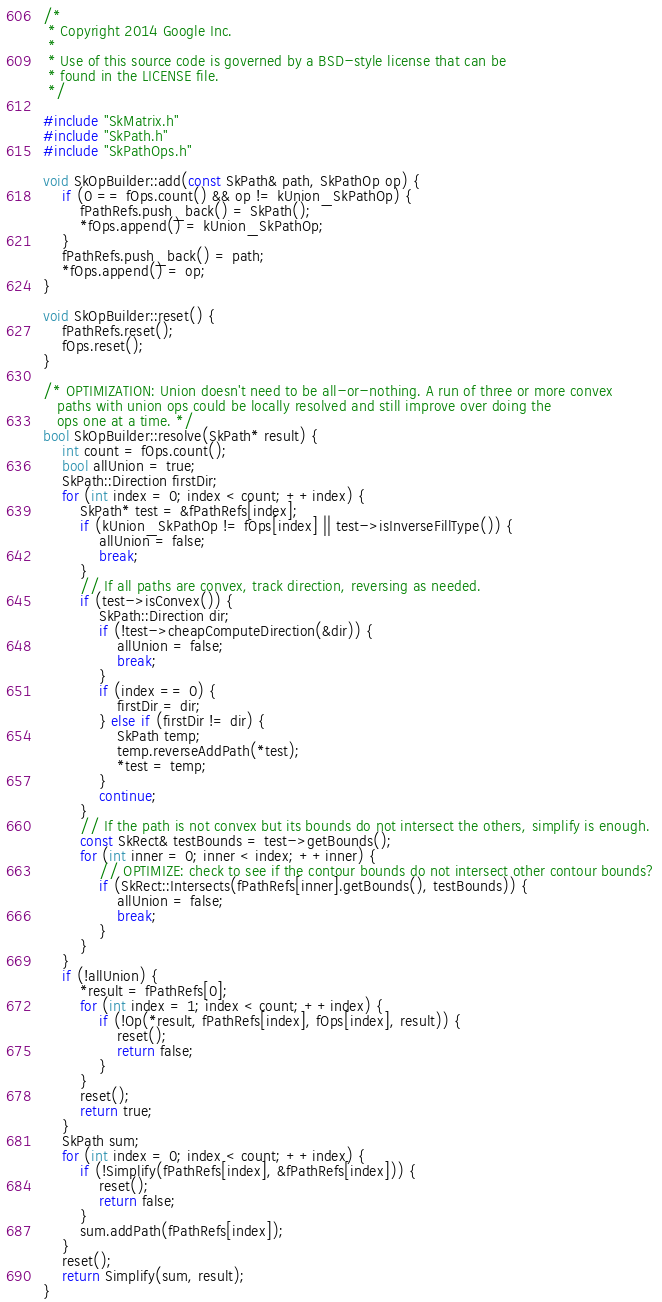<code> <loc_0><loc_0><loc_500><loc_500><_C++_>/*
 * Copyright 2014 Google Inc.
 *
 * Use of this source code is governed by a BSD-style license that can be
 * found in the LICENSE file.
 */

#include "SkMatrix.h"
#include "SkPath.h"
#include "SkPathOps.h"

void SkOpBuilder::add(const SkPath& path, SkPathOp op) {
    if (0 == fOps.count() && op != kUnion_SkPathOp) {
        fPathRefs.push_back() = SkPath();
        *fOps.append() = kUnion_SkPathOp;
    }
    fPathRefs.push_back() = path;
    *fOps.append() = op;
}

void SkOpBuilder::reset() {
    fPathRefs.reset();
    fOps.reset();
}

/* OPTIMIZATION: Union doesn't need to be all-or-nothing. A run of three or more convex
   paths with union ops could be locally resolved and still improve over doing the
   ops one at a time. */
bool SkOpBuilder::resolve(SkPath* result) {
    int count = fOps.count();
    bool allUnion = true;
    SkPath::Direction firstDir;
    for (int index = 0; index < count; ++index) {
        SkPath* test = &fPathRefs[index];
        if (kUnion_SkPathOp != fOps[index] || test->isInverseFillType()) {
            allUnion = false;
            break;
        }
        // If all paths are convex, track direction, reversing as needed.
        if (test->isConvex()) {
            SkPath::Direction dir;
            if (!test->cheapComputeDirection(&dir)) {
                allUnion = false;
                break;
            }
            if (index == 0) {
                firstDir = dir;
            } else if (firstDir != dir) {
                SkPath temp;
                temp.reverseAddPath(*test);
                *test = temp;
            }
            continue;
        }
        // If the path is not convex but its bounds do not intersect the others, simplify is enough.
        const SkRect& testBounds = test->getBounds();
        for (int inner = 0; inner < index; ++inner) {
            // OPTIMIZE: check to see if the contour bounds do not intersect other contour bounds?
            if (SkRect::Intersects(fPathRefs[inner].getBounds(), testBounds)) {
                allUnion = false;
                break;
            }
        }
    }
    if (!allUnion) {
        *result = fPathRefs[0];
        for (int index = 1; index < count; ++index) {
            if (!Op(*result, fPathRefs[index], fOps[index], result)) {
                reset();
                return false;
            }
        }
        reset();
        return true;
    }
    SkPath sum;
    for (int index = 0; index < count; ++index) {
        if (!Simplify(fPathRefs[index], &fPathRefs[index])) {
            reset();
            return false;
        }
        sum.addPath(fPathRefs[index]);
    }
    reset();
    return Simplify(sum, result);
}
</code> 